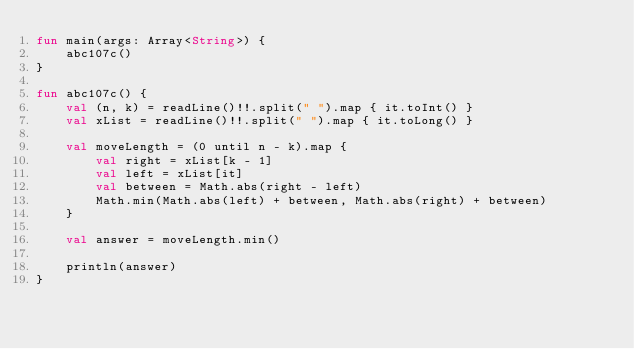Convert code to text. <code><loc_0><loc_0><loc_500><loc_500><_Kotlin_>fun main(args: Array<String>) {
    abc107c()
}

fun abc107c() {
    val (n, k) = readLine()!!.split(" ").map { it.toInt() }
    val xList = readLine()!!.split(" ").map { it.toLong() }

    val moveLength = (0 until n - k).map {
        val right = xList[k - 1]
        val left = xList[it]
        val between = Math.abs(right - left)
        Math.min(Math.abs(left) + between, Math.abs(right) + between)
    }

    val answer = moveLength.min()

    println(answer)
}
</code> 